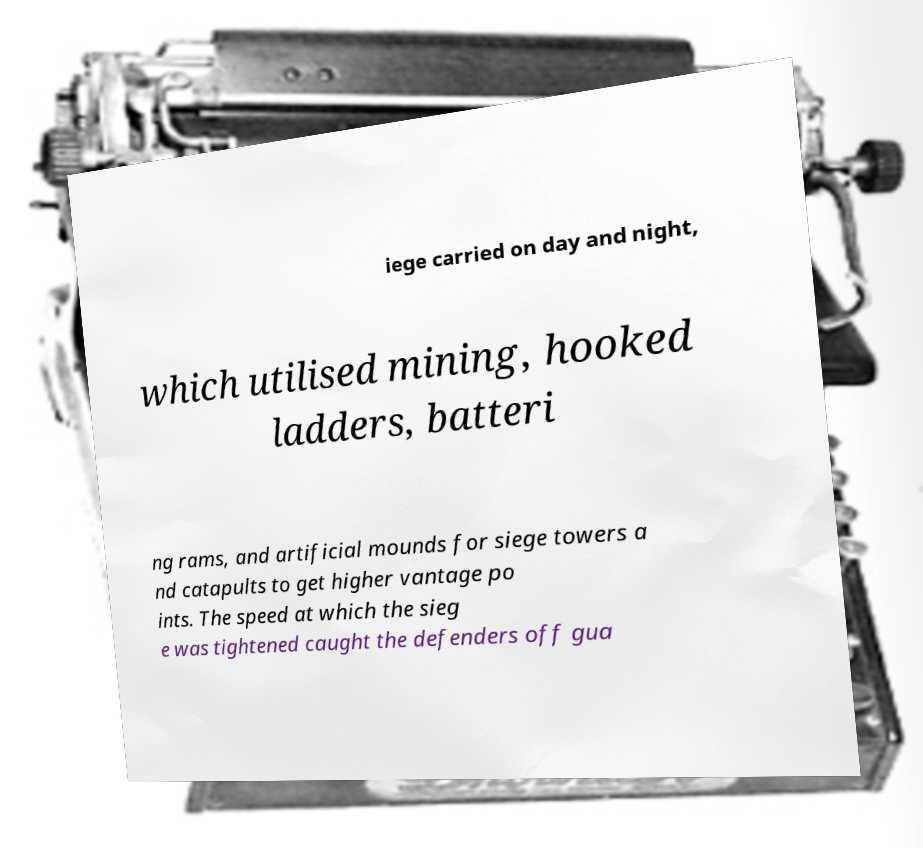For documentation purposes, I need the text within this image transcribed. Could you provide that? iege carried on day and night, which utilised mining, hooked ladders, batteri ng rams, and artificial mounds for siege towers a nd catapults to get higher vantage po ints. The speed at which the sieg e was tightened caught the defenders off gua 